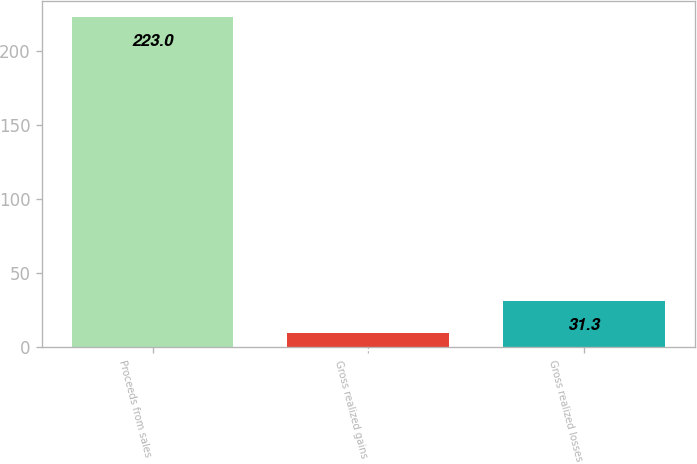<chart> <loc_0><loc_0><loc_500><loc_500><bar_chart><fcel>Proceeds from sales<fcel>Gross realized gains<fcel>Gross realized losses<nl><fcel>223<fcel>10<fcel>31.3<nl></chart> 